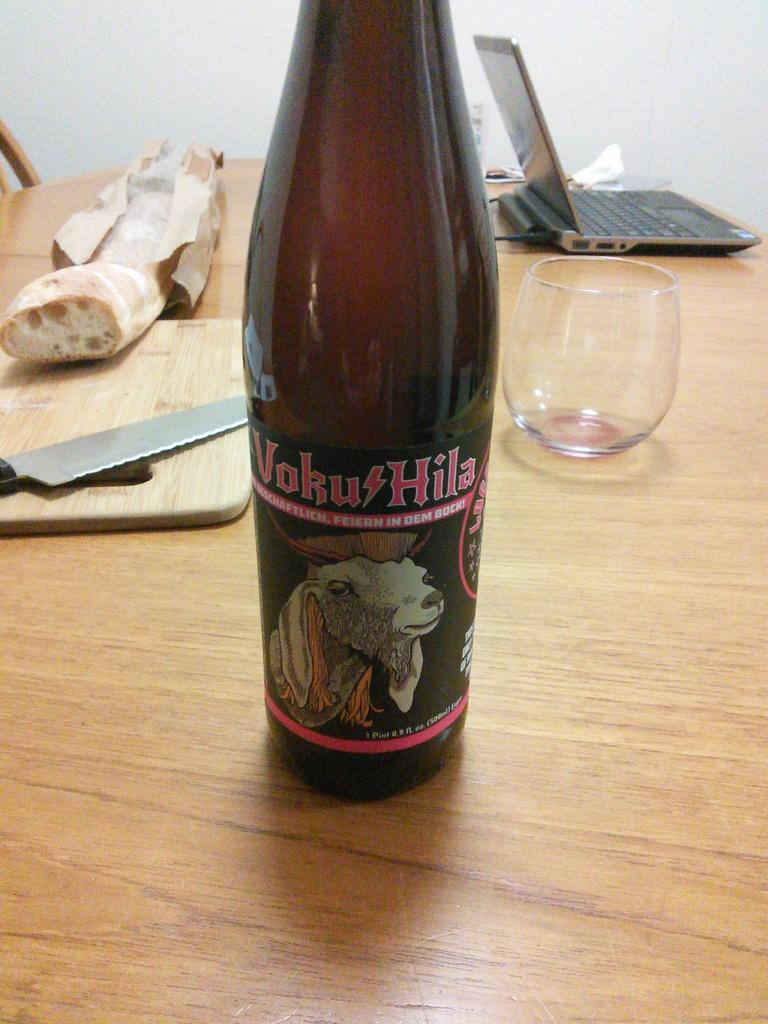What is the main piece of furniture in the image? There is a table in the image. What objects can be seen on the table? There is a bottle, a glass, a laptop, wood, a knife, bread, and a tissue paper on the table. What is the color of the wall in the background of the image? There is a white color wall in the background of the image. Can you see any carpenters working on the table in the image? There are no carpenters present in the image. What type of berry is being served on the table in the image? There are no berries present in the image; only bread and a knife are visible on the table. 